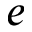Convert formula to latex. <formula><loc_0><loc_0><loc_500><loc_500>e</formula> 